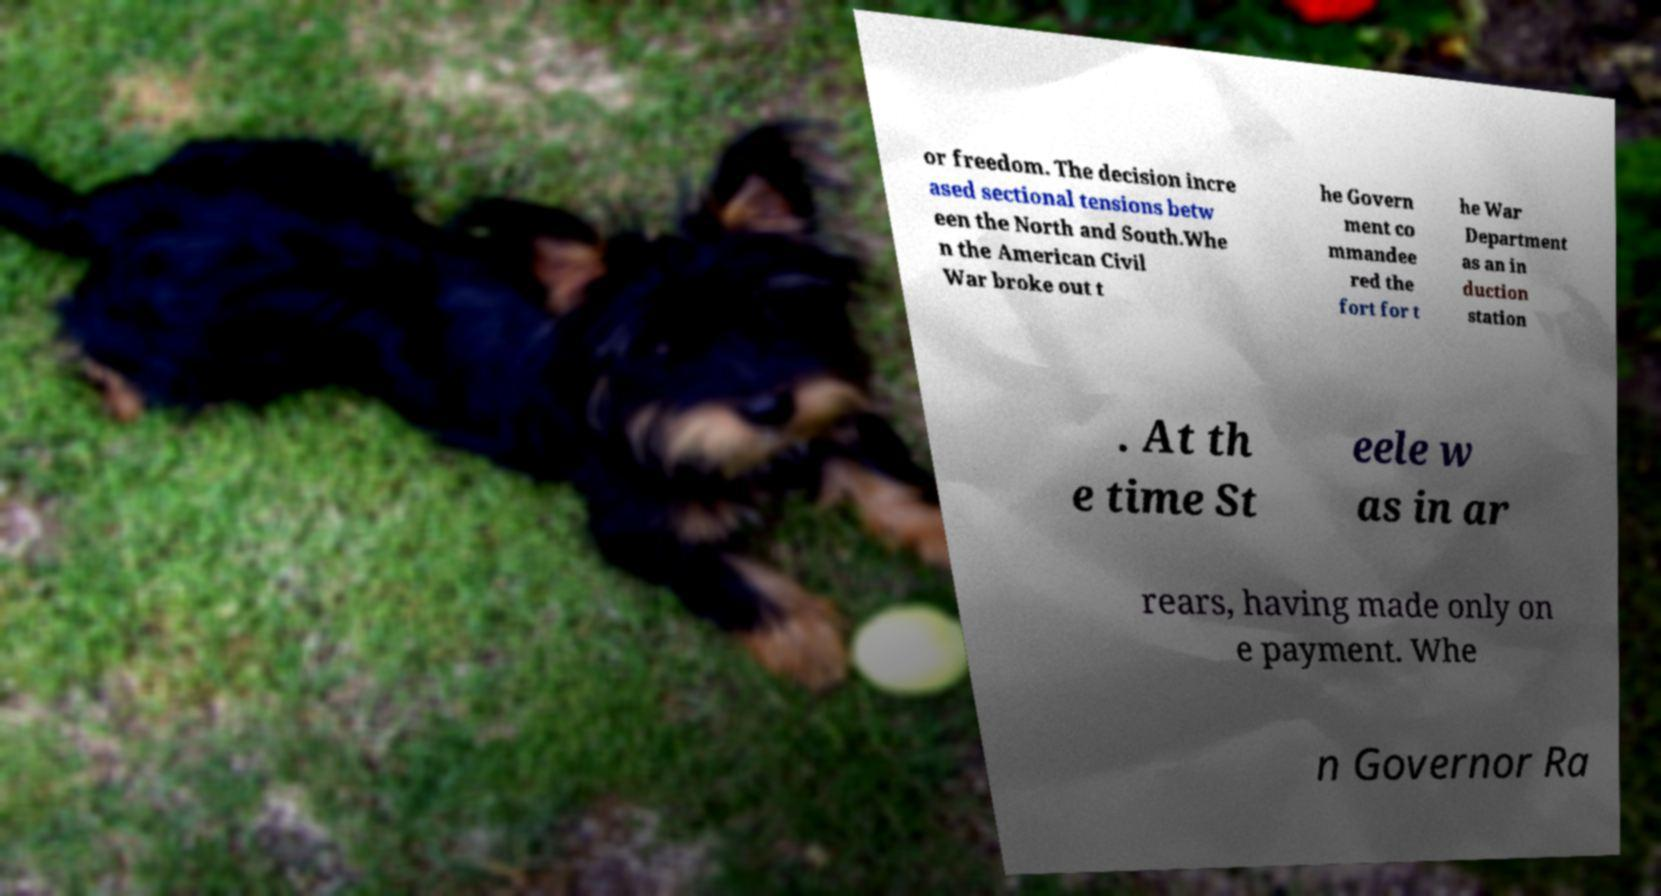Please read and relay the text visible in this image. What does it say? or freedom. The decision incre ased sectional tensions betw een the North and South.Whe n the American Civil War broke out t he Govern ment co mmandee red the fort for t he War Department as an in duction station . At th e time St eele w as in ar rears, having made only on e payment. Whe n Governor Ra 